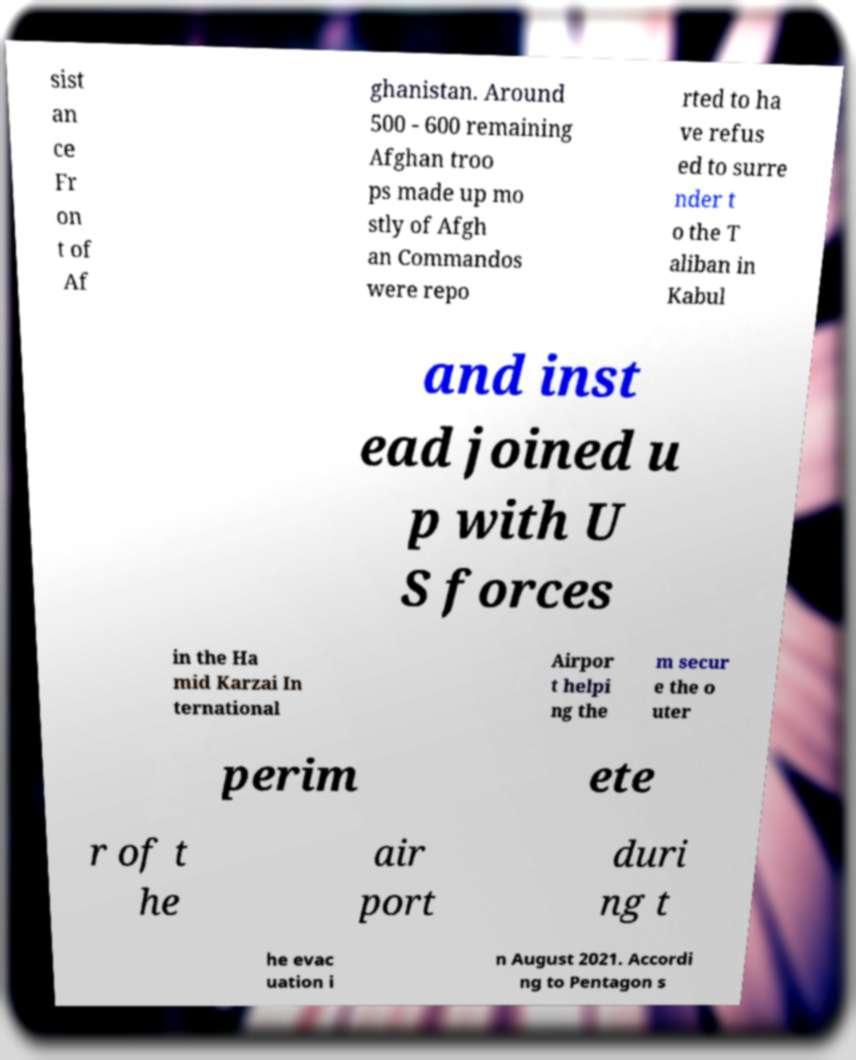Can you accurately transcribe the text from the provided image for me? sist an ce Fr on t of Af ghanistan. Around 500 - 600 remaining Afghan troo ps made up mo stly of Afgh an Commandos were repo rted to ha ve refus ed to surre nder t o the T aliban in Kabul and inst ead joined u p with U S forces in the Ha mid Karzai In ternational Airpor t helpi ng the m secur e the o uter perim ete r of t he air port duri ng t he evac uation i n August 2021. Accordi ng to Pentagon s 